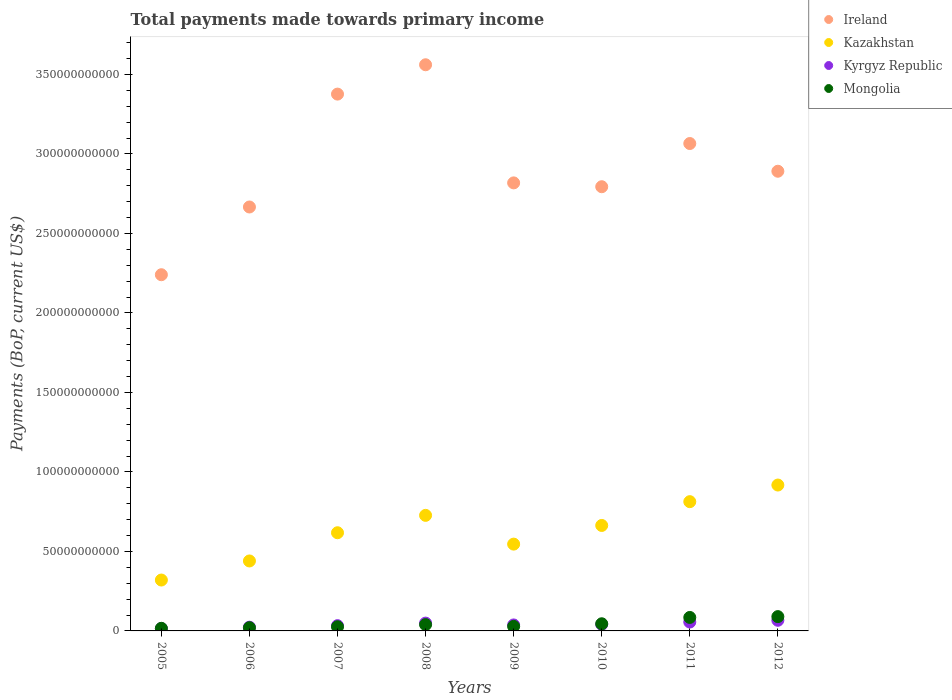How many different coloured dotlines are there?
Offer a very short reply. 4. What is the total payments made towards primary income in Ireland in 2007?
Your answer should be very brief. 3.38e+11. Across all years, what is the maximum total payments made towards primary income in Kyrgyz Republic?
Give a very brief answer. 6.69e+09. Across all years, what is the minimum total payments made towards primary income in Kyrgyz Republic?
Your answer should be very brief. 1.50e+09. In which year was the total payments made towards primary income in Mongolia maximum?
Your response must be concise. 2012. In which year was the total payments made towards primary income in Ireland minimum?
Keep it short and to the point. 2005. What is the total total payments made towards primary income in Mongolia in the graph?
Keep it short and to the point. 3.51e+1. What is the difference between the total payments made towards primary income in Ireland in 2007 and that in 2009?
Make the answer very short. 5.58e+1. What is the difference between the total payments made towards primary income in Kyrgyz Republic in 2005 and the total payments made towards primary income in Mongolia in 2007?
Provide a succinct answer. -1.13e+09. What is the average total payments made towards primary income in Kazakhstan per year?
Keep it short and to the point. 6.31e+1. In the year 2008, what is the difference between the total payments made towards primary income in Kyrgyz Republic and total payments made towards primary income in Ireland?
Your answer should be very brief. -3.51e+11. What is the ratio of the total payments made towards primary income in Ireland in 2010 to that in 2012?
Provide a succinct answer. 0.97. Is the total payments made towards primary income in Kazakhstan in 2008 less than that in 2009?
Provide a succinct answer. No. Is the difference between the total payments made towards primary income in Kyrgyz Republic in 2007 and 2011 greater than the difference between the total payments made towards primary income in Ireland in 2007 and 2011?
Your answer should be compact. No. What is the difference between the highest and the second highest total payments made towards primary income in Mongolia?
Make the answer very short. 5.24e+08. What is the difference between the highest and the lowest total payments made towards primary income in Kyrgyz Republic?
Your answer should be very brief. 5.19e+09. Is the sum of the total payments made towards primary income in Kazakhstan in 2009 and 2010 greater than the maximum total payments made towards primary income in Kyrgyz Republic across all years?
Your answer should be very brief. Yes. Is it the case that in every year, the sum of the total payments made towards primary income in Kazakhstan and total payments made towards primary income in Ireland  is greater than the total payments made towards primary income in Mongolia?
Your answer should be very brief. Yes. How many years are there in the graph?
Keep it short and to the point. 8. What is the difference between two consecutive major ticks on the Y-axis?
Offer a very short reply. 5.00e+1. Where does the legend appear in the graph?
Your answer should be compact. Top right. How are the legend labels stacked?
Make the answer very short. Vertical. What is the title of the graph?
Provide a succinct answer. Total payments made towards primary income. What is the label or title of the X-axis?
Provide a short and direct response. Years. What is the label or title of the Y-axis?
Offer a terse response. Payments (BoP, current US$). What is the Payments (BoP, current US$) in Ireland in 2005?
Make the answer very short. 2.24e+11. What is the Payments (BoP, current US$) in Kazakhstan in 2005?
Give a very brief answer. 3.20e+1. What is the Payments (BoP, current US$) in Kyrgyz Republic in 2005?
Provide a short and direct response. 1.50e+09. What is the Payments (BoP, current US$) in Mongolia in 2005?
Give a very brief answer. 1.63e+09. What is the Payments (BoP, current US$) of Ireland in 2006?
Offer a very short reply. 2.67e+11. What is the Payments (BoP, current US$) in Kazakhstan in 2006?
Make the answer very short. 4.40e+1. What is the Payments (BoP, current US$) in Kyrgyz Republic in 2006?
Offer a terse response. 2.34e+09. What is the Payments (BoP, current US$) in Mongolia in 2006?
Offer a very short reply. 2.04e+09. What is the Payments (BoP, current US$) in Ireland in 2007?
Give a very brief answer. 3.38e+11. What is the Payments (BoP, current US$) of Kazakhstan in 2007?
Ensure brevity in your answer.  6.18e+1. What is the Payments (BoP, current US$) of Kyrgyz Republic in 2007?
Make the answer very short. 3.31e+09. What is the Payments (BoP, current US$) of Mongolia in 2007?
Your response must be concise. 2.63e+09. What is the Payments (BoP, current US$) of Ireland in 2008?
Offer a very short reply. 3.56e+11. What is the Payments (BoP, current US$) in Kazakhstan in 2008?
Make the answer very short. 7.27e+1. What is the Payments (BoP, current US$) of Kyrgyz Republic in 2008?
Ensure brevity in your answer.  4.91e+09. What is the Payments (BoP, current US$) in Mongolia in 2008?
Make the answer very short. 3.96e+09. What is the Payments (BoP, current US$) of Ireland in 2009?
Offer a very short reply. 2.82e+11. What is the Payments (BoP, current US$) in Kazakhstan in 2009?
Give a very brief answer. 5.46e+1. What is the Payments (BoP, current US$) in Kyrgyz Republic in 2009?
Give a very brief answer. 3.76e+09. What is the Payments (BoP, current US$) of Mongolia in 2009?
Ensure brevity in your answer.  2.85e+09. What is the Payments (BoP, current US$) in Ireland in 2010?
Ensure brevity in your answer.  2.79e+11. What is the Payments (BoP, current US$) of Kazakhstan in 2010?
Offer a very short reply. 6.63e+1. What is the Payments (BoP, current US$) of Kyrgyz Republic in 2010?
Your answer should be very brief. 4.12e+09. What is the Payments (BoP, current US$) in Mongolia in 2010?
Keep it short and to the point. 4.50e+09. What is the Payments (BoP, current US$) in Ireland in 2011?
Keep it short and to the point. 3.07e+11. What is the Payments (BoP, current US$) of Kazakhstan in 2011?
Make the answer very short. 8.13e+1. What is the Payments (BoP, current US$) in Kyrgyz Republic in 2011?
Your answer should be compact. 5.59e+09. What is the Payments (BoP, current US$) in Mongolia in 2011?
Give a very brief answer. 8.48e+09. What is the Payments (BoP, current US$) of Ireland in 2012?
Offer a terse response. 2.89e+11. What is the Payments (BoP, current US$) of Kazakhstan in 2012?
Your answer should be very brief. 9.18e+1. What is the Payments (BoP, current US$) in Kyrgyz Republic in 2012?
Offer a very short reply. 6.69e+09. What is the Payments (BoP, current US$) of Mongolia in 2012?
Offer a terse response. 9.00e+09. Across all years, what is the maximum Payments (BoP, current US$) of Ireland?
Provide a short and direct response. 3.56e+11. Across all years, what is the maximum Payments (BoP, current US$) in Kazakhstan?
Ensure brevity in your answer.  9.18e+1. Across all years, what is the maximum Payments (BoP, current US$) of Kyrgyz Republic?
Keep it short and to the point. 6.69e+09. Across all years, what is the maximum Payments (BoP, current US$) of Mongolia?
Provide a succinct answer. 9.00e+09. Across all years, what is the minimum Payments (BoP, current US$) of Ireland?
Make the answer very short. 2.24e+11. Across all years, what is the minimum Payments (BoP, current US$) of Kazakhstan?
Offer a very short reply. 3.20e+1. Across all years, what is the minimum Payments (BoP, current US$) of Kyrgyz Republic?
Keep it short and to the point. 1.50e+09. Across all years, what is the minimum Payments (BoP, current US$) of Mongolia?
Your response must be concise. 1.63e+09. What is the total Payments (BoP, current US$) of Ireland in the graph?
Provide a succinct answer. 2.34e+12. What is the total Payments (BoP, current US$) in Kazakhstan in the graph?
Your answer should be very brief. 5.04e+11. What is the total Payments (BoP, current US$) of Kyrgyz Republic in the graph?
Offer a very short reply. 3.22e+1. What is the total Payments (BoP, current US$) of Mongolia in the graph?
Keep it short and to the point. 3.51e+1. What is the difference between the Payments (BoP, current US$) in Ireland in 2005 and that in 2006?
Make the answer very short. -4.26e+1. What is the difference between the Payments (BoP, current US$) in Kazakhstan in 2005 and that in 2006?
Offer a very short reply. -1.20e+1. What is the difference between the Payments (BoP, current US$) in Kyrgyz Republic in 2005 and that in 2006?
Give a very brief answer. -8.41e+08. What is the difference between the Payments (BoP, current US$) in Mongolia in 2005 and that in 2006?
Your answer should be compact. -4.07e+08. What is the difference between the Payments (BoP, current US$) of Ireland in 2005 and that in 2007?
Provide a succinct answer. -1.14e+11. What is the difference between the Payments (BoP, current US$) in Kazakhstan in 2005 and that in 2007?
Your answer should be compact. -2.97e+1. What is the difference between the Payments (BoP, current US$) of Kyrgyz Republic in 2005 and that in 2007?
Ensure brevity in your answer.  -1.81e+09. What is the difference between the Payments (BoP, current US$) in Mongolia in 2005 and that in 2007?
Your answer should be compact. -9.92e+08. What is the difference between the Payments (BoP, current US$) in Ireland in 2005 and that in 2008?
Ensure brevity in your answer.  -1.32e+11. What is the difference between the Payments (BoP, current US$) in Kazakhstan in 2005 and that in 2008?
Provide a succinct answer. -4.07e+1. What is the difference between the Payments (BoP, current US$) in Kyrgyz Republic in 2005 and that in 2008?
Ensure brevity in your answer.  -3.41e+09. What is the difference between the Payments (BoP, current US$) in Mongolia in 2005 and that in 2008?
Your response must be concise. -2.32e+09. What is the difference between the Payments (BoP, current US$) in Ireland in 2005 and that in 2009?
Ensure brevity in your answer.  -5.78e+1. What is the difference between the Payments (BoP, current US$) of Kazakhstan in 2005 and that in 2009?
Provide a short and direct response. -2.26e+1. What is the difference between the Payments (BoP, current US$) of Kyrgyz Republic in 2005 and that in 2009?
Provide a short and direct response. -2.26e+09. What is the difference between the Payments (BoP, current US$) of Mongolia in 2005 and that in 2009?
Offer a very short reply. -1.22e+09. What is the difference between the Payments (BoP, current US$) in Ireland in 2005 and that in 2010?
Provide a short and direct response. -5.54e+1. What is the difference between the Payments (BoP, current US$) of Kazakhstan in 2005 and that in 2010?
Ensure brevity in your answer.  -3.43e+1. What is the difference between the Payments (BoP, current US$) of Kyrgyz Republic in 2005 and that in 2010?
Offer a very short reply. -2.62e+09. What is the difference between the Payments (BoP, current US$) of Mongolia in 2005 and that in 2010?
Ensure brevity in your answer.  -2.86e+09. What is the difference between the Payments (BoP, current US$) in Ireland in 2005 and that in 2011?
Make the answer very short. -8.25e+1. What is the difference between the Payments (BoP, current US$) in Kazakhstan in 2005 and that in 2011?
Your answer should be compact. -4.93e+1. What is the difference between the Payments (BoP, current US$) in Kyrgyz Republic in 2005 and that in 2011?
Offer a very short reply. -4.09e+09. What is the difference between the Payments (BoP, current US$) of Mongolia in 2005 and that in 2011?
Ensure brevity in your answer.  -6.85e+09. What is the difference between the Payments (BoP, current US$) of Ireland in 2005 and that in 2012?
Provide a succinct answer. -6.51e+1. What is the difference between the Payments (BoP, current US$) in Kazakhstan in 2005 and that in 2012?
Offer a terse response. -5.97e+1. What is the difference between the Payments (BoP, current US$) of Kyrgyz Republic in 2005 and that in 2012?
Offer a terse response. -5.19e+09. What is the difference between the Payments (BoP, current US$) in Mongolia in 2005 and that in 2012?
Your answer should be very brief. -7.37e+09. What is the difference between the Payments (BoP, current US$) of Ireland in 2006 and that in 2007?
Provide a succinct answer. -7.10e+1. What is the difference between the Payments (BoP, current US$) of Kazakhstan in 2006 and that in 2007?
Offer a very short reply. -1.77e+1. What is the difference between the Payments (BoP, current US$) of Kyrgyz Republic in 2006 and that in 2007?
Give a very brief answer. -9.69e+08. What is the difference between the Payments (BoP, current US$) in Mongolia in 2006 and that in 2007?
Your answer should be very brief. -5.85e+08. What is the difference between the Payments (BoP, current US$) of Ireland in 2006 and that in 2008?
Keep it short and to the point. -8.95e+1. What is the difference between the Payments (BoP, current US$) in Kazakhstan in 2006 and that in 2008?
Ensure brevity in your answer.  -2.87e+1. What is the difference between the Payments (BoP, current US$) of Kyrgyz Republic in 2006 and that in 2008?
Give a very brief answer. -2.57e+09. What is the difference between the Payments (BoP, current US$) of Mongolia in 2006 and that in 2008?
Keep it short and to the point. -1.91e+09. What is the difference between the Payments (BoP, current US$) of Ireland in 2006 and that in 2009?
Give a very brief answer. -1.52e+1. What is the difference between the Payments (BoP, current US$) in Kazakhstan in 2006 and that in 2009?
Offer a terse response. -1.06e+1. What is the difference between the Payments (BoP, current US$) of Kyrgyz Republic in 2006 and that in 2009?
Make the answer very short. -1.42e+09. What is the difference between the Payments (BoP, current US$) of Mongolia in 2006 and that in 2009?
Ensure brevity in your answer.  -8.08e+08. What is the difference between the Payments (BoP, current US$) in Ireland in 2006 and that in 2010?
Ensure brevity in your answer.  -1.28e+1. What is the difference between the Payments (BoP, current US$) of Kazakhstan in 2006 and that in 2010?
Give a very brief answer. -2.23e+1. What is the difference between the Payments (BoP, current US$) in Kyrgyz Republic in 2006 and that in 2010?
Give a very brief answer. -1.77e+09. What is the difference between the Payments (BoP, current US$) of Mongolia in 2006 and that in 2010?
Your answer should be very brief. -2.45e+09. What is the difference between the Payments (BoP, current US$) in Ireland in 2006 and that in 2011?
Your answer should be compact. -3.99e+1. What is the difference between the Payments (BoP, current US$) in Kazakhstan in 2006 and that in 2011?
Ensure brevity in your answer.  -3.73e+1. What is the difference between the Payments (BoP, current US$) of Kyrgyz Republic in 2006 and that in 2011?
Offer a very short reply. -3.25e+09. What is the difference between the Payments (BoP, current US$) of Mongolia in 2006 and that in 2011?
Ensure brevity in your answer.  -6.44e+09. What is the difference between the Payments (BoP, current US$) of Ireland in 2006 and that in 2012?
Provide a short and direct response. -2.25e+1. What is the difference between the Payments (BoP, current US$) of Kazakhstan in 2006 and that in 2012?
Ensure brevity in your answer.  -4.77e+1. What is the difference between the Payments (BoP, current US$) in Kyrgyz Republic in 2006 and that in 2012?
Keep it short and to the point. -4.35e+09. What is the difference between the Payments (BoP, current US$) in Mongolia in 2006 and that in 2012?
Provide a short and direct response. -6.96e+09. What is the difference between the Payments (BoP, current US$) in Ireland in 2007 and that in 2008?
Offer a very short reply. -1.85e+1. What is the difference between the Payments (BoP, current US$) of Kazakhstan in 2007 and that in 2008?
Offer a very short reply. -1.09e+1. What is the difference between the Payments (BoP, current US$) in Kyrgyz Republic in 2007 and that in 2008?
Your answer should be very brief. -1.60e+09. What is the difference between the Payments (BoP, current US$) of Mongolia in 2007 and that in 2008?
Provide a short and direct response. -1.33e+09. What is the difference between the Payments (BoP, current US$) of Ireland in 2007 and that in 2009?
Keep it short and to the point. 5.58e+1. What is the difference between the Payments (BoP, current US$) in Kazakhstan in 2007 and that in 2009?
Provide a succinct answer. 7.15e+09. What is the difference between the Payments (BoP, current US$) in Kyrgyz Republic in 2007 and that in 2009?
Provide a short and direct response. -4.52e+08. What is the difference between the Payments (BoP, current US$) in Mongolia in 2007 and that in 2009?
Your answer should be very brief. -2.23e+08. What is the difference between the Payments (BoP, current US$) of Ireland in 2007 and that in 2010?
Offer a terse response. 5.83e+1. What is the difference between the Payments (BoP, current US$) in Kazakhstan in 2007 and that in 2010?
Ensure brevity in your answer.  -4.59e+09. What is the difference between the Payments (BoP, current US$) in Kyrgyz Republic in 2007 and that in 2010?
Make the answer very short. -8.06e+08. What is the difference between the Payments (BoP, current US$) of Mongolia in 2007 and that in 2010?
Give a very brief answer. -1.87e+09. What is the difference between the Payments (BoP, current US$) in Ireland in 2007 and that in 2011?
Ensure brevity in your answer.  3.11e+1. What is the difference between the Payments (BoP, current US$) in Kazakhstan in 2007 and that in 2011?
Your response must be concise. -1.96e+1. What is the difference between the Payments (BoP, current US$) of Kyrgyz Republic in 2007 and that in 2011?
Your answer should be compact. -2.28e+09. What is the difference between the Payments (BoP, current US$) of Mongolia in 2007 and that in 2011?
Offer a very short reply. -5.85e+09. What is the difference between the Payments (BoP, current US$) of Ireland in 2007 and that in 2012?
Offer a terse response. 4.85e+1. What is the difference between the Payments (BoP, current US$) in Kazakhstan in 2007 and that in 2012?
Ensure brevity in your answer.  -3.00e+1. What is the difference between the Payments (BoP, current US$) in Kyrgyz Republic in 2007 and that in 2012?
Offer a very short reply. -3.38e+09. What is the difference between the Payments (BoP, current US$) in Mongolia in 2007 and that in 2012?
Ensure brevity in your answer.  -6.38e+09. What is the difference between the Payments (BoP, current US$) in Ireland in 2008 and that in 2009?
Your answer should be compact. 7.43e+1. What is the difference between the Payments (BoP, current US$) of Kazakhstan in 2008 and that in 2009?
Your answer should be very brief. 1.81e+1. What is the difference between the Payments (BoP, current US$) of Kyrgyz Republic in 2008 and that in 2009?
Make the answer very short. 1.15e+09. What is the difference between the Payments (BoP, current US$) of Mongolia in 2008 and that in 2009?
Provide a succinct answer. 1.11e+09. What is the difference between the Payments (BoP, current US$) of Ireland in 2008 and that in 2010?
Give a very brief answer. 7.67e+1. What is the difference between the Payments (BoP, current US$) of Kazakhstan in 2008 and that in 2010?
Offer a very short reply. 6.35e+09. What is the difference between the Payments (BoP, current US$) of Kyrgyz Republic in 2008 and that in 2010?
Provide a succinct answer. 7.95e+08. What is the difference between the Payments (BoP, current US$) of Mongolia in 2008 and that in 2010?
Provide a succinct answer. -5.40e+08. What is the difference between the Payments (BoP, current US$) in Ireland in 2008 and that in 2011?
Keep it short and to the point. 4.95e+1. What is the difference between the Payments (BoP, current US$) in Kazakhstan in 2008 and that in 2011?
Ensure brevity in your answer.  -8.61e+09. What is the difference between the Payments (BoP, current US$) in Kyrgyz Republic in 2008 and that in 2011?
Your answer should be very brief. -6.79e+08. What is the difference between the Payments (BoP, current US$) in Mongolia in 2008 and that in 2011?
Your response must be concise. -4.52e+09. What is the difference between the Payments (BoP, current US$) in Ireland in 2008 and that in 2012?
Give a very brief answer. 6.70e+1. What is the difference between the Payments (BoP, current US$) of Kazakhstan in 2008 and that in 2012?
Offer a very short reply. -1.91e+1. What is the difference between the Payments (BoP, current US$) of Kyrgyz Republic in 2008 and that in 2012?
Your answer should be compact. -1.78e+09. What is the difference between the Payments (BoP, current US$) of Mongolia in 2008 and that in 2012?
Your answer should be very brief. -5.05e+09. What is the difference between the Payments (BoP, current US$) in Ireland in 2009 and that in 2010?
Offer a terse response. 2.41e+09. What is the difference between the Payments (BoP, current US$) of Kazakhstan in 2009 and that in 2010?
Your response must be concise. -1.17e+1. What is the difference between the Payments (BoP, current US$) of Kyrgyz Republic in 2009 and that in 2010?
Offer a terse response. -3.54e+08. What is the difference between the Payments (BoP, current US$) of Mongolia in 2009 and that in 2010?
Your response must be concise. -1.65e+09. What is the difference between the Payments (BoP, current US$) of Ireland in 2009 and that in 2011?
Provide a short and direct response. -2.48e+1. What is the difference between the Payments (BoP, current US$) in Kazakhstan in 2009 and that in 2011?
Your answer should be very brief. -2.67e+1. What is the difference between the Payments (BoP, current US$) in Kyrgyz Republic in 2009 and that in 2011?
Offer a very short reply. -1.83e+09. What is the difference between the Payments (BoP, current US$) in Mongolia in 2009 and that in 2011?
Give a very brief answer. -5.63e+09. What is the difference between the Payments (BoP, current US$) in Ireland in 2009 and that in 2012?
Your response must be concise. -7.33e+09. What is the difference between the Payments (BoP, current US$) of Kazakhstan in 2009 and that in 2012?
Offer a terse response. -3.72e+1. What is the difference between the Payments (BoP, current US$) in Kyrgyz Republic in 2009 and that in 2012?
Provide a short and direct response. -2.92e+09. What is the difference between the Payments (BoP, current US$) of Mongolia in 2009 and that in 2012?
Give a very brief answer. -6.15e+09. What is the difference between the Payments (BoP, current US$) of Ireland in 2010 and that in 2011?
Your answer should be very brief. -2.72e+1. What is the difference between the Payments (BoP, current US$) of Kazakhstan in 2010 and that in 2011?
Make the answer very short. -1.50e+1. What is the difference between the Payments (BoP, current US$) in Kyrgyz Republic in 2010 and that in 2011?
Your response must be concise. -1.47e+09. What is the difference between the Payments (BoP, current US$) in Mongolia in 2010 and that in 2011?
Offer a terse response. -3.98e+09. What is the difference between the Payments (BoP, current US$) in Ireland in 2010 and that in 2012?
Provide a succinct answer. -9.74e+09. What is the difference between the Payments (BoP, current US$) in Kazakhstan in 2010 and that in 2012?
Your answer should be very brief. -2.54e+1. What is the difference between the Payments (BoP, current US$) in Kyrgyz Republic in 2010 and that in 2012?
Ensure brevity in your answer.  -2.57e+09. What is the difference between the Payments (BoP, current US$) of Mongolia in 2010 and that in 2012?
Make the answer very short. -4.51e+09. What is the difference between the Payments (BoP, current US$) in Ireland in 2011 and that in 2012?
Offer a terse response. 1.74e+1. What is the difference between the Payments (BoP, current US$) in Kazakhstan in 2011 and that in 2012?
Keep it short and to the point. -1.05e+1. What is the difference between the Payments (BoP, current US$) of Kyrgyz Republic in 2011 and that in 2012?
Your answer should be compact. -1.10e+09. What is the difference between the Payments (BoP, current US$) of Mongolia in 2011 and that in 2012?
Give a very brief answer. -5.24e+08. What is the difference between the Payments (BoP, current US$) of Ireland in 2005 and the Payments (BoP, current US$) of Kazakhstan in 2006?
Your response must be concise. 1.80e+11. What is the difference between the Payments (BoP, current US$) in Ireland in 2005 and the Payments (BoP, current US$) in Kyrgyz Republic in 2006?
Keep it short and to the point. 2.22e+11. What is the difference between the Payments (BoP, current US$) in Ireland in 2005 and the Payments (BoP, current US$) in Mongolia in 2006?
Your answer should be very brief. 2.22e+11. What is the difference between the Payments (BoP, current US$) in Kazakhstan in 2005 and the Payments (BoP, current US$) in Kyrgyz Republic in 2006?
Offer a very short reply. 2.97e+1. What is the difference between the Payments (BoP, current US$) in Kazakhstan in 2005 and the Payments (BoP, current US$) in Mongolia in 2006?
Provide a succinct answer. 3.00e+1. What is the difference between the Payments (BoP, current US$) in Kyrgyz Republic in 2005 and the Payments (BoP, current US$) in Mongolia in 2006?
Provide a succinct answer. -5.41e+08. What is the difference between the Payments (BoP, current US$) in Ireland in 2005 and the Payments (BoP, current US$) in Kazakhstan in 2007?
Offer a terse response. 1.62e+11. What is the difference between the Payments (BoP, current US$) of Ireland in 2005 and the Payments (BoP, current US$) of Kyrgyz Republic in 2007?
Your answer should be compact. 2.21e+11. What is the difference between the Payments (BoP, current US$) of Ireland in 2005 and the Payments (BoP, current US$) of Mongolia in 2007?
Your answer should be compact. 2.21e+11. What is the difference between the Payments (BoP, current US$) of Kazakhstan in 2005 and the Payments (BoP, current US$) of Kyrgyz Republic in 2007?
Give a very brief answer. 2.87e+1. What is the difference between the Payments (BoP, current US$) in Kazakhstan in 2005 and the Payments (BoP, current US$) in Mongolia in 2007?
Your answer should be compact. 2.94e+1. What is the difference between the Payments (BoP, current US$) of Kyrgyz Republic in 2005 and the Payments (BoP, current US$) of Mongolia in 2007?
Your answer should be compact. -1.13e+09. What is the difference between the Payments (BoP, current US$) in Ireland in 2005 and the Payments (BoP, current US$) in Kazakhstan in 2008?
Give a very brief answer. 1.51e+11. What is the difference between the Payments (BoP, current US$) in Ireland in 2005 and the Payments (BoP, current US$) in Kyrgyz Republic in 2008?
Your answer should be compact. 2.19e+11. What is the difference between the Payments (BoP, current US$) of Ireland in 2005 and the Payments (BoP, current US$) of Mongolia in 2008?
Your answer should be compact. 2.20e+11. What is the difference between the Payments (BoP, current US$) in Kazakhstan in 2005 and the Payments (BoP, current US$) in Kyrgyz Republic in 2008?
Make the answer very short. 2.71e+1. What is the difference between the Payments (BoP, current US$) of Kazakhstan in 2005 and the Payments (BoP, current US$) of Mongolia in 2008?
Provide a short and direct response. 2.81e+1. What is the difference between the Payments (BoP, current US$) of Kyrgyz Republic in 2005 and the Payments (BoP, current US$) of Mongolia in 2008?
Your answer should be very brief. -2.46e+09. What is the difference between the Payments (BoP, current US$) of Ireland in 2005 and the Payments (BoP, current US$) of Kazakhstan in 2009?
Offer a very short reply. 1.69e+11. What is the difference between the Payments (BoP, current US$) in Ireland in 2005 and the Payments (BoP, current US$) in Kyrgyz Republic in 2009?
Ensure brevity in your answer.  2.20e+11. What is the difference between the Payments (BoP, current US$) of Ireland in 2005 and the Payments (BoP, current US$) of Mongolia in 2009?
Your answer should be very brief. 2.21e+11. What is the difference between the Payments (BoP, current US$) of Kazakhstan in 2005 and the Payments (BoP, current US$) of Kyrgyz Republic in 2009?
Make the answer very short. 2.82e+1. What is the difference between the Payments (BoP, current US$) of Kazakhstan in 2005 and the Payments (BoP, current US$) of Mongolia in 2009?
Give a very brief answer. 2.92e+1. What is the difference between the Payments (BoP, current US$) of Kyrgyz Republic in 2005 and the Payments (BoP, current US$) of Mongolia in 2009?
Provide a succinct answer. -1.35e+09. What is the difference between the Payments (BoP, current US$) in Ireland in 2005 and the Payments (BoP, current US$) in Kazakhstan in 2010?
Your response must be concise. 1.58e+11. What is the difference between the Payments (BoP, current US$) in Ireland in 2005 and the Payments (BoP, current US$) in Kyrgyz Republic in 2010?
Ensure brevity in your answer.  2.20e+11. What is the difference between the Payments (BoP, current US$) in Ireland in 2005 and the Payments (BoP, current US$) in Mongolia in 2010?
Offer a terse response. 2.20e+11. What is the difference between the Payments (BoP, current US$) of Kazakhstan in 2005 and the Payments (BoP, current US$) of Kyrgyz Republic in 2010?
Ensure brevity in your answer.  2.79e+1. What is the difference between the Payments (BoP, current US$) of Kazakhstan in 2005 and the Payments (BoP, current US$) of Mongolia in 2010?
Make the answer very short. 2.75e+1. What is the difference between the Payments (BoP, current US$) in Kyrgyz Republic in 2005 and the Payments (BoP, current US$) in Mongolia in 2010?
Give a very brief answer. -3.00e+09. What is the difference between the Payments (BoP, current US$) in Ireland in 2005 and the Payments (BoP, current US$) in Kazakhstan in 2011?
Make the answer very short. 1.43e+11. What is the difference between the Payments (BoP, current US$) in Ireland in 2005 and the Payments (BoP, current US$) in Kyrgyz Republic in 2011?
Provide a succinct answer. 2.18e+11. What is the difference between the Payments (BoP, current US$) in Ireland in 2005 and the Payments (BoP, current US$) in Mongolia in 2011?
Offer a terse response. 2.16e+11. What is the difference between the Payments (BoP, current US$) of Kazakhstan in 2005 and the Payments (BoP, current US$) of Kyrgyz Republic in 2011?
Provide a succinct answer. 2.64e+1. What is the difference between the Payments (BoP, current US$) in Kazakhstan in 2005 and the Payments (BoP, current US$) in Mongolia in 2011?
Your response must be concise. 2.35e+1. What is the difference between the Payments (BoP, current US$) of Kyrgyz Republic in 2005 and the Payments (BoP, current US$) of Mongolia in 2011?
Offer a terse response. -6.98e+09. What is the difference between the Payments (BoP, current US$) of Ireland in 2005 and the Payments (BoP, current US$) of Kazakhstan in 2012?
Your answer should be very brief. 1.32e+11. What is the difference between the Payments (BoP, current US$) in Ireland in 2005 and the Payments (BoP, current US$) in Kyrgyz Republic in 2012?
Your response must be concise. 2.17e+11. What is the difference between the Payments (BoP, current US$) in Ireland in 2005 and the Payments (BoP, current US$) in Mongolia in 2012?
Provide a succinct answer. 2.15e+11. What is the difference between the Payments (BoP, current US$) in Kazakhstan in 2005 and the Payments (BoP, current US$) in Kyrgyz Republic in 2012?
Ensure brevity in your answer.  2.53e+1. What is the difference between the Payments (BoP, current US$) in Kazakhstan in 2005 and the Payments (BoP, current US$) in Mongolia in 2012?
Provide a succinct answer. 2.30e+1. What is the difference between the Payments (BoP, current US$) of Kyrgyz Republic in 2005 and the Payments (BoP, current US$) of Mongolia in 2012?
Make the answer very short. -7.50e+09. What is the difference between the Payments (BoP, current US$) in Ireland in 2006 and the Payments (BoP, current US$) in Kazakhstan in 2007?
Your answer should be compact. 2.05e+11. What is the difference between the Payments (BoP, current US$) in Ireland in 2006 and the Payments (BoP, current US$) in Kyrgyz Republic in 2007?
Provide a short and direct response. 2.63e+11. What is the difference between the Payments (BoP, current US$) in Ireland in 2006 and the Payments (BoP, current US$) in Mongolia in 2007?
Provide a short and direct response. 2.64e+11. What is the difference between the Payments (BoP, current US$) of Kazakhstan in 2006 and the Payments (BoP, current US$) of Kyrgyz Republic in 2007?
Keep it short and to the point. 4.07e+1. What is the difference between the Payments (BoP, current US$) in Kazakhstan in 2006 and the Payments (BoP, current US$) in Mongolia in 2007?
Make the answer very short. 4.14e+1. What is the difference between the Payments (BoP, current US$) in Kyrgyz Republic in 2006 and the Payments (BoP, current US$) in Mongolia in 2007?
Give a very brief answer. -2.85e+08. What is the difference between the Payments (BoP, current US$) in Ireland in 2006 and the Payments (BoP, current US$) in Kazakhstan in 2008?
Your response must be concise. 1.94e+11. What is the difference between the Payments (BoP, current US$) in Ireland in 2006 and the Payments (BoP, current US$) in Kyrgyz Republic in 2008?
Keep it short and to the point. 2.62e+11. What is the difference between the Payments (BoP, current US$) of Ireland in 2006 and the Payments (BoP, current US$) of Mongolia in 2008?
Offer a very short reply. 2.63e+11. What is the difference between the Payments (BoP, current US$) of Kazakhstan in 2006 and the Payments (BoP, current US$) of Kyrgyz Republic in 2008?
Give a very brief answer. 3.91e+1. What is the difference between the Payments (BoP, current US$) in Kazakhstan in 2006 and the Payments (BoP, current US$) in Mongolia in 2008?
Offer a very short reply. 4.01e+1. What is the difference between the Payments (BoP, current US$) in Kyrgyz Republic in 2006 and the Payments (BoP, current US$) in Mongolia in 2008?
Your answer should be compact. -1.61e+09. What is the difference between the Payments (BoP, current US$) of Ireland in 2006 and the Payments (BoP, current US$) of Kazakhstan in 2009?
Offer a very short reply. 2.12e+11. What is the difference between the Payments (BoP, current US$) in Ireland in 2006 and the Payments (BoP, current US$) in Kyrgyz Republic in 2009?
Make the answer very short. 2.63e+11. What is the difference between the Payments (BoP, current US$) of Ireland in 2006 and the Payments (BoP, current US$) of Mongolia in 2009?
Offer a very short reply. 2.64e+11. What is the difference between the Payments (BoP, current US$) of Kazakhstan in 2006 and the Payments (BoP, current US$) of Kyrgyz Republic in 2009?
Provide a short and direct response. 4.02e+1. What is the difference between the Payments (BoP, current US$) of Kazakhstan in 2006 and the Payments (BoP, current US$) of Mongolia in 2009?
Offer a terse response. 4.12e+1. What is the difference between the Payments (BoP, current US$) in Kyrgyz Republic in 2006 and the Payments (BoP, current US$) in Mongolia in 2009?
Offer a very short reply. -5.08e+08. What is the difference between the Payments (BoP, current US$) of Ireland in 2006 and the Payments (BoP, current US$) of Kazakhstan in 2010?
Provide a succinct answer. 2.00e+11. What is the difference between the Payments (BoP, current US$) of Ireland in 2006 and the Payments (BoP, current US$) of Kyrgyz Republic in 2010?
Offer a terse response. 2.63e+11. What is the difference between the Payments (BoP, current US$) of Ireland in 2006 and the Payments (BoP, current US$) of Mongolia in 2010?
Your answer should be very brief. 2.62e+11. What is the difference between the Payments (BoP, current US$) of Kazakhstan in 2006 and the Payments (BoP, current US$) of Kyrgyz Republic in 2010?
Keep it short and to the point. 3.99e+1. What is the difference between the Payments (BoP, current US$) in Kazakhstan in 2006 and the Payments (BoP, current US$) in Mongolia in 2010?
Your answer should be very brief. 3.95e+1. What is the difference between the Payments (BoP, current US$) in Kyrgyz Republic in 2006 and the Payments (BoP, current US$) in Mongolia in 2010?
Make the answer very short. -2.15e+09. What is the difference between the Payments (BoP, current US$) in Ireland in 2006 and the Payments (BoP, current US$) in Kazakhstan in 2011?
Your answer should be compact. 1.85e+11. What is the difference between the Payments (BoP, current US$) of Ireland in 2006 and the Payments (BoP, current US$) of Kyrgyz Republic in 2011?
Provide a short and direct response. 2.61e+11. What is the difference between the Payments (BoP, current US$) of Ireland in 2006 and the Payments (BoP, current US$) of Mongolia in 2011?
Your answer should be very brief. 2.58e+11. What is the difference between the Payments (BoP, current US$) of Kazakhstan in 2006 and the Payments (BoP, current US$) of Kyrgyz Republic in 2011?
Provide a succinct answer. 3.84e+1. What is the difference between the Payments (BoP, current US$) in Kazakhstan in 2006 and the Payments (BoP, current US$) in Mongolia in 2011?
Offer a terse response. 3.55e+1. What is the difference between the Payments (BoP, current US$) in Kyrgyz Republic in 2006 and the Payments (BoP, current US$) in Mongolia in 2011?
Offer a terse response. -6.14e+09. What is the difference between the Payments (BoP, current US$) in Ireland in 2006 and the Payments (BoP, current US$) in Kazakhstan in 2012?
Provide a short and direct response. 1.75e+11. What is the difference between the Payments (BoP, current US$) in Ireland in 2006 and the Payments (BoP, current US$) in Kyrgyz Republic in 2012?
Ensure brevity in your answer.  2.60e+11. What is the difference between the Payments (BoP, current US$) of Ireland in 2006 and the Payments (BoP, current US$) of Mongolia in 2012?
Keep it short and to the point. 2.58e+11. What is the difference between the Payments (BoP, current US$) of Kazakhstan in 2006 and the Payments (BoP, current US$) of Kyrgyz Republic in 2012?
Keep it short and to the point. 3.73e+1. What is the difference between the Payments (BoP, current US$) in Kazakhstan in 2006 and the Payments (BoP, current US$) in Mongolia in 2012?
Your answer should be very brief. 3.50e+1. What is the difference between the Payments (BoP, current US$) in Kyrgyz Republic in 2006 and the Payments (BoP, current US$) in Mongolia in 2012?
Your response must be concise. -6.66e+09. What is the difference between the Payments (BoP, current US$) of Ireland in 2007 and the Payments (BoP, current US$) of Kazakhstan in 2008?
Your answer should be very brief. 2.65e+11. What is the difference between the Payments (BoP, current US$) in Ireland in 2007 and the Payments (BoP, current US$) in Kyrgyz Republic in 2008?
Your answer should be compact. 3.33e+11. What is the difference between the Payments (BoP, current US$) of Ireland in 2007 and the Payments (BoP, current US$) of Mongolia in 2008?
Offer a terse response. 3.34e+11. What is the difference between the Payments (BoP, current US$) in Kazakhstan in 2007 and the Payments (BoP, current US$) in Kyrgyz Republic in 2008?
Give a very brief answer. 5.68e+1. What is the difference between the Payments (BoP, current US$) of Kazakhstan in 2007 and the Payments (BoP, current US$) of Mongolia in 2008?
Offer a terse response. 5.78e+1. What is the difference between the Payments (BoP, current US$) of Kyrgyz Republic in 2007 and the Payments (BoP, current US$) of Mongolia in 2008?
Offer a terse response. -6.44e+08. What is the difference between the Payments (BoP, current US$) of Ireland in 2007 and the Payments (BoP, current US$) of Kazakhstan in 2009?
Provide a short and direct response. 2.83e+11. What is the difference between the Payments (BoP, current US$) of Ireland in 2007 and the Payments (BoP, current US$) of Kyrgyz Republic in 2009?
Provide a short and direct response. 3.34e+11. What is the difference between the Payments (BoP, current US$) in Ireland in 2007 and the Payments (BoP, current US$) in Mongolia in 2009?
Offer a very short reply. 3.35e+11. What is the difference between the Payments (BoP, current US$) of Kazakhstan in 2007 and the Payments (BoP, current US$) of Kyrgyz Republic in 2009?
Give a very brief answer. 5.80e+1. What is the difference between the Payments (BoP, current US$) of Kazakhstan in 2007 and the Payments (BoP, current US$) of Mongolia in 2009?
Make the answer very short. 5.89e+1. What is the difference between the Payments (BoP, current US$) in Kyrgyz Republic in 2007 and the Payments (BoP, current US$) in Mongolia in 2009?
Ensure brevity in your answer.  4.62e+08. What is the difference between the Payments (BoP, current US$) of Ireland in 2007 and the Payments (BoP, current US$) of Kazakhstan in 2010?
Your answer should be very brief. 2.71e+11. What is the difference between the Payments (BoP, current US$) of Ireland in 2007 and the Payments (BoP, current US$) of Kyrgyz Republic in 2010?
Give a very brief answer. 3.34e+11. What is the difference between the Payments (BoP, current US$) in Ireland in 2007 and the Payments (BoP, current US$) in Mongolia in 2010?
Ensure brevity in your answer.  3.33e+11. What is the difference between the Payments (BoP, current US$) of Kazakhstan in 2007 and the Payments (BoP, current US$) of Kyrgyz Republic in 2010?
Provide a short and direct response. 5.76e+1. What is the difference between the Payments (BoP, current US$) of Kazakhstan in 2007 and the Payments (BoP, current US$) of Mongolia in 2010?
Give a very brief answer. 5.73e+1. What is the difference between the Payments (BoP, current US$) in Kyrgyz Republic in 2007 and the Payments (BoP, current US$) in Mongolia in 2010?
Provide a short and direct response. -1.18e+09. What is the difference between the Payments (BoP, current US$) in Ireland in 2007 and the Payments (BoP, current US$) in Kazakhstan in 2011?
Your answer should be very brief. 2.56e+11. What is the difference between the Payments (BoP, current US$) in Ireland in 2007 and the Payments (BoP, current US$) in Kyrgyz Republic in 2011?
Offer a terse response. 3.32e+11. What is the difference between the Payments (BoP, current US$) of Ireland in 2007 and the Payments (BoP, current US$) of Mongolia in 2011?
Ensure brevity in your answer.  3.29e+11. What is the difference between the Payments (BoP, current US$) in Kazakhstan in 2007 and the Payments (BoP, current US$) in Kyrgyz Republic in 2011?
Keep it short and to the point. 5.62e+1. What is the difference between the Payments (BoP, current US$) in Kazakhstan in 2007 and the Payments (BoP, current US$) in Mongolia in 2011?
Provide a succinct answer. 5.33e+1. What is the difference between the Payments (BoP, current US$) in Kyrgyz Republic in 2007 and the Payments (BoP, current US$) in Mongolia in 2011?
Your answer should be compact. -5.17e+09. What is the difference between the Payments (BoP, current US$) of Ireland in 2007 and the Payments (BoP, current US$) of Kazakhstan in 2012?
Give a very brief answer. 2.46e+11. What is the difference between the Payments (BoP, current US$) of Ireland in 2007 and the Payments (BoP, current US$) of Kyrgyz Republic in 2012?
Make the answer very short. 3.31e+11. What is the difference between the Payments (BoP, current US$) of Ireland in 2007 and the Payments (BoP, current US$) of Mongolia in 2012?
Give a very brief answer. 3.29e+11. What is the difference between the Payments (BoP, current US$) in Kazakhstan in 2007 and the Payments (BoP, current US$) in Kyrgyz Republic in 2012?
Your response must be concise. 5.51e+1. What is the difference between the Payments (BoP, current US$) of Kazakhstan in 2007 and the Payments (BoP, current US$) of Mongolia in 2012?
Provide a succinct answer. 5.27e+1. What is the difference between the Payments (BoP, current US$) in Kyrgyz Republic in 2007 and the Payments (BoP, current US$) in Mongolia in 2012?
Provide a succinct answer. -5.69e+09. What is the difference between the Payments (BoP, current US$) in Ireland in 2008 and the Payments (BoP, current US$) in Kazakhstan in 2009?
Offer a terse response. 3.02e+11. What is the difference between the Payments (BoP, current US$) in Ireland in 2008 and the Payments (BoP, current US$) in Kyrgyz Republic in 2009?
Your answer should be compact. 3.52e+11. What is the difference between the Payments (BoP, current US$) of Ireland in 2008 and the Payments (BoP, current US$) of Mongolia in 2009?
Give a very brief answer. 3.53e+11. What is the difference between the Payments (BoP, current US$) in Kazakhstan in 2008 and the Payments (BoP, current US$) in Kyrgyz Republic in 2009?
Your response must be concise. 6.89e+1. What is the difference between the Payments (BoP, current US$) in Kazakhstan in 2008 and the Payments (BoP, current US$) in Mongolia in 2009?
Your answer should be compact. 6.98e+1. What is the difference between the Payments (BoP, current US$) of Kyrgyz Republic in 2008 and the Payments (BoP, current US$) of Mongolia in 2009?
Offer a terse response. 2.06e+09. What is the difference between the Payments (BoP, current US$) of Ireland in 2008 and the Payments (BoP, current US$) of Kazakhstan in 2010?
Your answer should be very brief. 2.90e+11. What is the difference between the Payments (BoP, current US$) of Ireland in 2008 and the Payments (BoP, current US$) of Kyrgyz Republic in 2010?
Ensure brevity in your answer.  3.52e+11. What is the difference between the Payments (BoP, current US$) of Ireland in 2008 and the Payments (BoP, current US$) of Mongolia in 2010?
Make the answer very short. 3.52e+11. What is the difference between the Payments (BoP, current US$) in Kazakhstan in 2008 and the Payments (BoP, current US$) in Kyrgyz Republic in 2010?
Make the answer very short. 6.86e+1. What is the difference between the Payments (BoP, current US$) of Kazakhstan in 2008 and the Payments (BoP, current US$) of Mongolia in 2010?
Your answer should be compact. 6.82e+1. What is the difference between the Payments (BoP, current US$) of Kyrgyz Republic in 2008 and the Payments (BoP, current US$) of Mongolia in 2010?
Make the answer very short. 4.16e+08. What is the difference between the Payments (BoP, current US$) in Ireland in 2008 and the Payments (BoP, current US$) in Kazakhstan in 2011?
Provide a succinct answer. 2.75e+11. What is the difference between the Payments (BoP, current US$) in Ireland in 2008 and the Payments (BoP, current US$) in Kyrgyz Republic in 2011?
Provide a succinct answer. 3.51e+11. What is the difference between the Payments (BoP, current US$) of Ireland in 2008 and the Payments (BoP, current US$) of Mongolia in 2011?
Ensure brevity in your answer.  3.48e+11. What is the difference between the Payments (BoP, current US$) of Kazakhstan in 2008 and the Payments (BoP, current US$) of Kyrgyz Republic in 2011?
Offer a terse response. 6.71e+1. What is the difference between the Payments (BoP, current US$) of Kazakhstan in 2008 and the Payments (BoP, current US$) of Mongolia in 2011?
Offer a terse response. 6.42e+1. What is the difference between the Payments (BoP, current US$) of Kyrgyz Republic in 2008 and the Payments (BoP, current US$) of Mongolia in 2011?
Your answer should be compact. -3.57e+09. What is the difference between the Payments (BoP, current US$) of Ireland in 2008 and the Payments (BoP, current US$) of Kazakhstan in 2012?
Keep it short and to the point. 2.64e+11. What is the difference between the Payments (BoP, current US$) of Ireland in 2008 and the Payments (BoP, current US$) of Kyrgyz Republic in 2012?
Make the answer very short. 3.49e+11. What is the difference between the Payments (BoP, current US$) in Ireland in 2008 and the Payments (BoP, current US$) in Mongolia in 2012?
Keep it short and to the point. 3.47e+11. What is the difference between the Payments (BoP, current US$) in Kazakhstan in 2008 and the Payments (BoP, current US$) in Kyrgyz Republic in 2012?
Ensure brevity in your answer.  6.60e+1. What is the difference between the Payments (BoP, current US$) in Kazakhstan in 2008 and the Payments (BoP, current US$) in Mongolia in 2012?
Your response must be concise. 6.37e+1. What is the difference between the Payments (BoP, current US$) of Kyrgyz Republic in 2008 and the Payments (BoP, current US$) of Mongolia in 2012?
Provide a succinct answer. -4.09e+09. What is the difference between the Payments (BoP, current US$) of Ireland in 2009 and the Payments (BoP, current US$) of Kazakhstan in 2010?
Offer a very short reply. 2.15e+11. What is the difference between the Payments (BoP, current US$) in Ireland in 2009 and the Payments (BoP, current US$) in Kyrgyz Republic in 2010?
Your answer should be compact. 2.78e+11. What is the difference between the Payments (BoP, current US$) in Ireland in 2009 and the Payments (BoP, current US$) in Mongolia in 2010?
Offer a terse response. 2.77e+11. What is the difference between the Payments (BoP, current US$) in Kazakhstan in 2009 and the Payments (BoP, current US$) in Kyrgyz Republic in 2010?
Offer a very short reply. 5.05e+1. What is the difference between the Payments (BoP, current US$) in Kazakhstan in 2009 and the Payments (BoP, current US$) in Mongolia in 2010?
Offer a terse response. 5.01e+1. What is the difference between the Payments (BoP, current US$) in Kyrgyz Republic in 2009 and the Payments (BoP, current US$) in Mongolia in 2010?
Your answer should be compact. -7.33e+08. What is the difference between the Payments (BoP, current US$) in Ireland in 2009 and the Payments (BoP, current US$) in Kazakhstan in 2011?
Provide a short and direct response. 2.01e+11. What is the difference between the Payments (BoP, current US$) of Ireland in 2009 and the Payments (BoP, current US$) of Kyrgyz Republic in 2011?
Ensure brevity in your answer.  2.76e+11. What is the difference between the Payments (BoP, current US$) of Ireland in 2009 and the Payments (BoP, current US$) of Mongolia in 2011?
Your answer should be compact. 2.73e+11. What is the difference between the Payments (BoP, current US$) in Kazakhstan in 2009 and the Payments (BoP, current US$) in Kyrgyz Republic in 2011?
Make the answer very short. 4.90e+1. What is the difference between the Payments (BoP, current US$) in Kazakhstan in 2009 and the Payments (BoP, current US$) in Mongolia in 2011?
Offer a very short reply. 4.61e+1. What is the difference between the Payments (BoP, current US$) in Kyrgyz Republic in 2009 and the Payments (BoP, current US$) in Mongolia in 2011?
Provide a short and direct response. -4.72e+09. What is the difference between the Payments (BoP, current US$) of Ireland in 2009 and the Payments (BoP, current US$) of Kazakhstan in 2012?
Offer a very short reply. 1.90e+11. What is the difference between the Payments (BoP, current US$) in Ireland in 2009 and the Payments (BoP, current US$) in Kyrgyz Republic in 2012?
Your response must be concise. 2.75e+11. What is the difference between the Payments (BoP, current US$) in Ireland in 2009 and the Payments (BoP, current US$) in Mongolia in 2012?
Offer a very short reply. 2.73e+11. What is the difference between the Payments (BoP, current US$) of Kazakhstan in 2009 and the Payments (BoP, current US$) of Kyrgyz Republic in 2012?
Make the answer very short. 4.79e+1. What is the difference between the Payments (BoP, current US$) of Kazakhstan in 2009 and the Payments (BoP, current US$) of Mongolia in 2012?
Offer a terse response. 4.56e+1. What is the difference between the Payments (BoP, current US$) in Kyrgyz Republic in 2009 and the Payments (BoP, current US$) in Mongolia in 2012?
Offer a very short reply. -5.24e+09. What is the difference between the Payments (BoP, current US$) in Ireland in 2010 and the Payments (BoP, current US$) in Kazakhstan in 2011?
Give a very brief answer. 1.98e+11. What is the difference between the Payments (BoP, current US$) of Ireland in 2010 and the Payments (BoP, current US$) of Kyrgyz Republic in 2011?
Make the answer very short. 2.74e+11. What is the difference between the Payments (BoP, current US$) in Ireland in 2010 and the Payments (BoP, current US$) in Mongolia in 2011?
Your response must be concise. 2.71e+11. What is the difference between the Payments (BoP, current US$) of Kazakhstan in 2010 and the Payments (BoP, current US$) of Kyrgyz Republic in 2011?
Give a very brief answer. 6.07e+1. What is the difference between the Payments (BoP, current US$) of Kazakhstan in 2010 and the Payments (BoP, current US$) of Mongolia in 2011?
Provide a succinct answer. 5.79e+1. What is the difference between the Payments (BoP, current US$) in Kyrgyz Republic in 2010 and the Payments (BoP, current US$) in Mongolia in 2011?
Keep it short and to the point. -4.36e+09. What is the difference between the Payments (BoP, current US$) in Ireland in 2010 and the Payments (BoP, current US$) in Kazakhstan in 2012?
Keep it short and to the point. 1.88e+11. What is the difference between the Payments (BoP, current US$) in Ireland in 2010 and the Payments (BoP, current US$) in Kyrgyz Republic in 2012?
Offer a terse response. 2.73e+11. What is the difference between the Payments (BoP, current US$) of Ireland in 2010 and the Payments (BoP, current US$) of Mongolia in 2012?
Offer a terse response. 2.70e+11. What is the difference between the Payments (BoP, current US$) of Kazakhstan in 2010 and the Payments (BoP, current US$) of Kyrgyz Republic in 2012?
Your answer should be compact. 5.96e+1. What is the difference between the Payments (BoP, current US$) in Kazakhstan in 2010 and the Payments (BoP, current US$) in Mongolia in 2012?
Ensure brevity in your answer.  5.73e+1. What is the difference between the Payments (BoP, current US$) of Kyrgyz Republic in 2010 and the Payments (BoP, current US$) of Mongolia in 2012?
Your answer should be very brief. -4.89e+09. What is the difference between the Payments (BoP, current US$) of Ireland in 2011 and the Payments (BoP, current US$) of Kazakhstan in 2012?
Provide a short and direct response. 2.15e+11. What is the difference between the Payments (BoP, current US$) in Ireland in 2011 and the Payments (BoP, current US$) in Kyrgyz Republic in 2012?
Provide a succinct answer. 3.00e+11. What is the difference between the Payments (BoP, current US$) of Ireland in 2011 and the Payments (BoP, current US$) of Mongolia in 2012?
Your answer should be very brief. 2.98e+11. What is the difference between the Payments (BoP, current US$) of Kazakhstan in 2011 and the Payments (BoP, current US$) of Kyrgyz Republic in 2012?
Provide a short and direct response. 7.46e+1. What is the difference between the Payments (BoP, current US$) of Kazakhstan in 2011 and the Payments (BoP, current US$) of Mongolia in 2012?
Keep it short and to the point. 7.23e+1. What is the difference between the Payments (BoP, current US$) in Kyrgyz Republic in 2011 and the Payments (BoP, current US$) in Mongolia in 2012?
Keep it short and to the point. -3.41e+09. What is the average Payments (BoP, current US$) in Ireland per year?
Offer a very short reply. 2.93e+11. What is the average Payments (BoP, current US$) of Kazakhstan per year?
Your answer should be very brief. 6.31e+1. What is the average Payments (BoP, current US$) in Kyrgyz Republic per year?
Offer a very short reply. 4.03e+09. What is the average Payments (BoP, current US$) in Mongolia per year?
Make the answer very short. 4.39e+09. In the year 2005, what is the difference between the Payments (BoP, current US$) of Ireland and Payments (BoP, current US$) of Kazakhstan?
Provide a succinct answer. 1.92e+11. In the year 2005, what is the difference between the Payments (BoP, current US$) of Ireland and Payments (BoP, current US$) of Kyrgyz Republic?
Your answer should be compact. 2.23e+11. In the year 2005, what is the difference between the Payments (BoP, current US$) of Ireland and Payments (BoP, current US$) of Mongolia?
Your response must be concise. 2.22e+11. In the year 2005, what is the difference between the Payments (BoP, current US$) of Kazakhstan and Payments (BoP, current US$) of Kyrgyz Republic?
Offer a terse response. 3.05e+1. In the year 2005, what is the difference between the Payments (BoP, current US$) of Kazakhstan and Payments (BoP, current US$) of Mongolia?
Offer a very short reply. 3.04e+1. In the year 2005, what is the difference between the Payments (BoP, current US$) in Kyrgyz Republic and Payments (BoP, current US$) in Mongolia?
Give a very brief answer. -1.34e+08. In the year 2006, what is the difference between the Payments (BoP, current US$) in Ireland and Payments (BoP, current US$) in Kazakhstan?
Provide a succinct answer. 2.23e+11. In the year 2006, what is the difference between the Payments (BoP, current US$) of Ireland and Payments (BoP, current US$) of Kyrgyz Republic?
Give a very brief answer. 2.64e+11. In the year 2006, what is the difference between the Payments (BoP, current US$) in Ireland and Payments (BoP, current US$) in Mongolia?
Offer a terse response. 2.65e+11. In the year 2006, what is the difference between the Payments (BoP, current US$) in Kazakhstan and Payments (BoP, current US$) in Kyrgyz Republic?
Offer a terse response. 4.17e+1. In the year 2006, what is the difference between the Payments (BoP, current US$) of Kazakhstan and Payments (BoP, current US$) of Mongolia?
Offer a very short reply. 4.20e+1. In the year 2006, what is the difference between the Payments (BoP, current US$) of Kyrgyz Republic and Payments (BoP, current US$) of Mongolia?
Provide a short and direct response. 3.00e+08. In the year 2007, what is the difference between the Payments (BoP, current US$) of Ireland and Payments (BoP, current US$) of Kazakhstan?
Keep it short and to the point. 2.76e+11. In the year 2007, what is the difference between the Payments (BoP, current US$) of Ireland and Payments (BoP, current US$) of Kyrgyz Republic?
Ensure brevity in your answer.  3.34e+11. In the year 2007, what is the difference between the Payments (BoP, current US$) of Ireland and Payments (BoP, current US$) of Mongolia?
Provide a succinct answer. 3.35e+11. In the year 2007, what is the difference between the Payments (BoP, current US$) in Kazakhstan and Payments (BoP, current US$) in Kyrgyz Republic?
Ensure brevity in your answer.  5.84e+1. In the year 2007, what is the difference between the Payments (BoP, current US$) in Kazakhstan and Payments (BoP, current US$) in Mongolia?
Give a very brief answer. 5.91e+1. In the year 2007, what is the difference between the Payments (BoP, current US$) of Kyrgyz Republic and Payments (BoP, current US$) of Mongolia?
Your answer should be compact. 6.85e+08. In the year 2008, what is the difference between the Payments (BoP, current US$) in Ireland and Payments (BoP, current US$) in Kazakhstan?
Provide a succinct answer. 2.83e+11. In the year 2008, what is the difference between the Payments (BoP, current US$) in Ireland and Payments (BoP, current US$) in Kyrgyz Republic?
Your answer should be very brief. 3.51e+11. In the year 2008, what is the difference between the Payments (BoP, current US$) of Ireland and Payments (BoP, current US$) of Mongolia?
Offer a very short reply. 3.52e+11. In the year 2008, what is the difference between the Payments (BoP, current US$) of Kazakhstan and Payments (BoP, current US$) of Kyrgyz Republic?
Offer a very short reply. 6.78e+1. In the year 2008, what is the difference between the Payments (BoP, current US$) in Kazakhstan and Payments (BoP, current US$) in Mongolia?
Offer a terse response. 6.87e+1. In the year 2008, what is the difference between the Payments (BoP, current US$) in Kyrgyz Republic and Payments (BoP, current US$) in Mongolia?
Your answer should be compact. 9.56e+08. In the year 2009, what is the difference between the Payments (BoP, current US$) in Ireland and Payments (BoP, current US$) in Kazakhstan?
Provide a succinct answer. 2.27e+11. In the year 2009, what is the difference between the Payments (BoP, current US$) in Ireland and Payments (BoP, current US$) in Kyrgyz Republic?
Offer a terse response. 2.78e+11. In the year 2009, what is the difference between the Payments (BoP, current US$) in Ireland and Payments (BoP, current US$) in Mongolia?
Give a very brief answer. 2.79e+11. In the year 2009, what is the difference between the Payments (BoP, current US$) in Kazakhstan and Payments (BoP, current US$) in Kyrgyz Republic?
Make the answer very short. 5.08e+1. In the year 2009, what is the difference between the Payments (BoP, current US$) of Kazakhstan and Payments (BoP, current US$) of Mongolia?
Your answer should be very brief. 5.17e+1. In the year 2009, what is the difference between the Payments (BoP, current US$) of Kyrgyz Republic and Payments (BoP, current US$) of Mongolia?
Offer a very short reply. 9.13e+08. In the year 2010, what is the difference between the Payments (BoP, current US$) of Ireland and Payments (BoP, current US$) of Kazakhstan?
Give a very brief answer. 2.13e+11. In the year 2010, what is the difference between the Payments (BoP, current US$) of Ireland and Payments (BoP, current US$) of Kyrgyz Republic?
Your response must be concise. 2.75e+11. In the year 2010, what is the difference between the Payments (BoP, current US$) in Ireland and Payments (BoP, current US$) in Mongolia?
Provide a short and direct response. 2.75e+11. In the year 2010, what is the difference between the Payments (BoP, current US$) of Kazakhstan and Payments (BoP, current US$) of Kyrgyz Republic?
Make the answer very short. 6.22e+1. In the year 2010, what is the difference between the Payments (BoP, current US$) in Kazakhstan and Payments (BoP, current US$) in Mongolia?
Your answer should be very brief. 6.18e+1. In the year 2010, what is the difference between the Payments (BoP, current US$) of Kyrgyz Republic and Payments (BoP, current US$) of Mongolia?
Make the answer very short. -3.79e+08. In the year 2011, what is the difference between the Payments (BoP, current US$) in Ireland and Payments (BoP, current US$) in Kazakhstan?
Make the answer very short. 2.25e+11. In the year 2011, what is the difference between the Payments (BoP, current US$) in Ireland and Payments (BoP, current US$) in Kyrgyz Republic?
Provide a succinct answer. 3.01e+11. In the year 2011, what is the difference between the Payments (BoP, current US$) of Ireland and Payments (BoP, current US$) of Mongolia?
Offer a very short reply. 2.98e+11. In the year 2011, what is the difference between the Payments (BoP, current US$) of Kazakhstan and Payments (BoP, current US$) of Kyrgyz Republic?
Make the answer very short. 7.57e+1. In the year 2011, what is the difference between the Payments (BoP, current US$) of Kazakhstan and Payments (BoP, current US$) of Mongolia?
Make the answer very short. 7.28e+1. In the year 2011, what is the difference between the Payments (BoP, current US$) in Kyrgyz Republic and Payments (BoP, current US$) in Mongolia?
Provide a succinct answer. -2.89e+09. In the year 2012, what is the difference between the Payments (BoP, current US$) in Ireland and Payments (BoP, current US$) in Kazakhstan?
Provide a short and direct response. 1.97e+11. In the year 2012, what is the difference between the Payments (BoP, current US$) of Ireland and Payments (BoP, current US$) of Kyrgyz Republic?
Make the answer very short. 2.82e+11. In the year 2012, what is the difference between the Payments (BoP, current US$) of Ireland and Payments (BoP, current US$) of Mongolia?
Offer a terse response. 2.80e+11. In the year 2012, what is the difference between the Payments (BoP, current US$) of Kazakhstan and Payments (BoP, current US$) of Kyrgyz Republic?
Provide a succinct answer. 8.51e+1. In the year 2012, what is the difference between the Payments (BoP, current US$) of Kazakhstan and Payments (BoP, current US$) of Mongolia?
Offer a terse response. 8.28e+1. In the year 2012, what is the difference between the Payments (BoP, current US$) of Kyrgyz Republic and Payments (BoP, current US$) of Mongolia?
Your answer should be compact. -2.32e+09. What is the ratio of the Payments (BoP, current US$) in Ireland in 2005 to that in 2006?
Keep it short and to the point. 0.84. What is the ratio of the Payments (BoP, current US$) of Kazakhstan in 2005 to that in 2006?
Your answer should be compact. 0.73. What is the ratio of the Payments (BoP, current US$) of Kyrgyz Republic in 2005 to that in 2006?
Ensure brevity in your answer.  0.64. What is the ratio of the Payments (BoP, current US$) of Mongolia in 2005 to that in 2006?
Offer a very short reply. 0.8. What is the ratio of the Payments (BoP, current US$) in Ireland in 2005 to that in 2007?
Ensure brevity in your answer.  0.66. What is the ratio of the Payments (BoP, current US$) in Kazakhstan in 2005 to that in 2007?
Ensure brevity in your answer.  0.52. What is the ratio of the Payments (BoP, current US$) of Kyrgyz Republic in 2005 to that in 2007?
Your answer should be very brief. 0.45. What is the ratio of the Payments (BoP, current US$) of Mongolia in 2005 to that in 2007?
Provide a short and direct response. 0.62. What is the ratio of the Payments (BoP, current US$) of Ireland in 2005 to that in 2008?
Provide a short and direct response. 0.63. What is the ratio of the Payments (BoP, current US$) in Kazakhstan in 2005 to that in 2008?
Make the answer very short. 0.44. What is the ratio of the Payments (BoP, current US$) of Kyrgyz Republic in 2005 to that in 2008?
Make the answer very short. 0.31. What is the ratio of the Payments (BoP, current US$) in Mongolia in 2005 to that in 2008?
Provide a short and direct response. 0.41. What is the ratio of the Payments (BoP, current US$) of Ireland in 2005 to that in 2009?
Ensure brevity in your answer.  0.8. What is the ratio of the Payments (BoP, current US$) in Kazakhstan in 2005 to that in 2009?
Your response must be concise. 0.59. What is the ratio of the Payments (BoP, current US$) of Kyrgyz Republic in 2005 to that in 2009?
Make the answer very short. 0.4. What is the ratio of the Payments (BoP, current US$) in Mongolia in 2005 to that in 2009?
Make the answer very short. 0.57. What is the ratio of the Payments (BoP, current US$) in Ireland in 2005 to that in 2010?
Provide a succinct answer. 0.8. What is the ratio of the Payments (BoP, current US$) of Kazakhstan in 2005 to that in 2010?
Offer a terse response. 0.48. What is the ratio of the Payments (BoP, current US$) of Kyrgyz Republic in 2005 to that in 2010?
Ensure brevity in your answer.  0.36. What is the ratio of the Payments (BoP, current US$) of Mongolia in 2005 to that in 2010?
Offer a terse response. 0.36. What is the ratio of the Payments (BoP, current US$) in Ireland in 2005 to that in 2011?
Your answer should be compact. 0.73. What is the ratio of the Payments (BoP, current US$) of Kazakhstan in 2005 to that in 2011?
Make the answer very short. 0.39. What is the ratio of the Payments (BoP, current US$) of Kyrgyz Republic in 2005 to that in 2011?
Keep it short and to the point. 0.27. What is the ratio of the Payments (BoP, current US$) of Mongolia in 2005 to that in 2011?
Give a very brief answer. 0.19. What is the ratio of the Payments (BoP, current US$) of Ireland in 2005 to that in 2012?
Provide a short and direct response. 0.77. What is the ratio of the Payments (BoP, current US$) in Kazakhstan in 2005 to that in 2012?
Offer a very short reply. 0.35. What is the ratio of the Payments (BoP, current US$) in Kyrgyz Republic in 2005 to that in 2012?
Provide a short and direct response. 0.22. What is the ratio of the Payments (BoP, current US$) of Mongolia in 2005 to that in 2012?
Your answer should be very brief. 0.18. What is the ratio of the Payments (BoP, current US$) in Ireland in 2006 to that in 2007?
Provide a succinct answer. 0.79. What is the ratio of the Payments (BoP, current US$) of Kazakhstan in 2006 to that in 2007?
Give a very brief answer. 0.71. What is the ratio of the Payments (BoP, current US$) in Kyrgyz Republic in 2006 to that in 2007?
Your answer should be very brief. 0.71. What is the ratio of the Payments (BoP, current US$) of Mongolia in 2006 to that in 2007?
Your response must be concise. 0.78. What is the ratio of the Payments (BoP, current US$) of Ireland in 2006 to that in 2008?
Give a very brief answer. 0.75. What is the ratio of the Payments (BoP, current US$) in Kazakhstan in 2006 to that in 2008?
Your response must be concise. 0.61. What is the ratio of the Payments (BoP, current US$) of Kyrgyz Republic in 2006 to that in 2008?
Ensure brevity in your answer.  0.48. What is the ratio of the Payments (BoP, current US$) of Mongolia in 2006 to that in 2008?
Provide a succinct answer. 0.52. What is the ratio of the Payments (BoP, current US$) of Ireland in 2006 to that in 2009?
Your response must be concise. 0.95. What is the ratio of the Payments (BoP, current US$) of Kazakhstan in 2006 to that in 2009?
Your response must be concise. 0.81. What is the ratio of the Payments (BoP, current US$) of Kyrgyz Republic in 2006 to that in 2009?
Provide a short and direct response. 0.62. What is the ratio of the Payments (BoP, current US$) in Mongolia in 2006 to that in 2009?
Keep it short and to the point. 0.72. What is the ratio of the Payments (BoP, current US$) in Ireland in 2006 to that in 2010?
Provide a short and direct response. 0.95. What is the ratio of the Payments (BoP, current US$) of Kazakhstan in 2006 to that in 2010?
Your answer should be very brief. 0.66. What is the ratio of the Payments (BoP, current US$) in Kyrgyz Republic in 2006 to that in 2010?
Provide a short and direct response. 0.57. What is the ratio of the Payments (BoP, current US$) of Mongolia in 2006 to that in 2010?
Ensure brevity in your answer.  0.45. What is the ratio of the Payments (BoP, current US$) of Ireland in 2006 to that in 2011?
Give a very brief answer. 0.87. What is the ratio of the Payments (BoP, current US$) of Kazakhstan in 2006 to that in 2011?
Provide a succinct answer. 0.54. What is the ratio of the Payments (BoP, current US$) in Kyrgyz Republic in 2006 to that in 2011?
Provide a short and direct response. 0.42. What is the ratio of the Payments (BoP, current US$) in Mongolia in 2006 to that in 2011?
Offer a very short reply. 0.24. What is the ratio of the Payments (BoP, current US$) in Ireland in 2006 to that in 2012?
Provide a short and direct response. 0.92. What is the ratio of the Payments (BoP, current US$) in Kazakhstan in 2006 to that in 2012?
Your answer should be compact. 0.48. What is the ratio of the Payments (BoP, current US$) in Kyrgyz Republic in 2006 to that in 2012?
Your answer should be compact. 0.35. What is the ratio of the Payments (BoP, current US$) in Mongolia in 2006 to that in 2012?
Your answer should be compact. 0.23. What is the ratio of the Payments (BoP, current US$) of Ireland in 2007 to that in 2008?
Keep it short and to the point. 0.95. What is the ratio of the Payments (BoP, current US$) in Kazakhstan in 2007 to that in 2008?
Offer a terse response. 0.85. What is the ratio of the Payments (BoP, current US$) in Kyrgyz Republic in 2007 to that in 2008?
Your response must be concise. 0.67. What is the ratio of the Payments (BoP, current US$) in Mongolia in 2007 to that in 2008?
Provide a short and direct response. 0.66. What is the ratio of the Payments (BoP, current US$) in Ireland in 2007 to that in 2009?
Offer a very short reply. 1.2. What is the ratio of the Payments (BoP, current US$) in Kazakhstan in 2007 to that in 2009?
Ensure brevity in your answer.  1.13. What is the ratio of the Payments (BoP, current US$) in Mongolia in 2007 to that in 2009?
Provide a short and direct response. 0.92. What is the ratio of the Payments (BoP, current US$) in Ireland in 2007 to that in 2010?
Ensure brevity in your answer.  1.21. What is the ratio of the Payments (BoP, current US$) in Kazakhstan in 2007 to that in 2010?
Provide a succinct answer. 0.93. What is the ratio of the Payments (BoP, current US$) of Kyrgyz Republic in 2007 to that in 2010?
Offer a very short reply. 0.8. What is the ratio of the Payments (BoP, current US$) of Mongolia in 2007 to that in 2010?
Your answer should be very brief. 0.58. What is the ratio of the Payments (BoP, current US$) of Ireland in 2007 to that in 2011?
Make the answer very short. 1.1. What is the ratio of the Payments (BoP, current US$) of Kazakhstan in 2007 to that in 2011?
Keep it short and to the point. 0.76. What is the ratio of the Payments (BoP, current US$) of Kyrgyz Republic in 2007 to that in 2011?
Give a very brief answer. 0.59. What is the ratio of the Payments (BoP, current US$) in Mongolia in 2007 to that in 2011?
Offer a very short reply. 0.31. What is the ratio of the Payments (BoP, current US$) in Ireland in 2007 to that in 2012?
Keep it short and to the point. 1.17. What is the ratio of the Payments (BoP, current US$) of Kazakhstan in 2007 to that in 2012?
Ensure brevity in your answer.  0.67. What is the ratio of the Payments (BoP, current US$) in Kyrgyz Republic in 2007 to that in 2012?
Your answer should be very brief. 0.5. What is the ratio of the Payments (BoP, current US$) in Mongolia in 2007 to that in 2012?
Give a very brief answer. 0.29. What is the ratio of the Payments (BoP, current US$) of Ireland in 2008 to that in 2009?
Your answer should be compact. 1.26. What is the ratio of the Payments (BoP, current US$) in Kazakhstan in 2008 to that in 2009?
Provide a short and direct response. 1.33. What is the ratio of the Payments (BoP, current US$) of Kyrgyz Republic in 2008 to that in 2009?
Give a very brief answer. 1.31. What is the ratio of the Payments (BoP, current US$) in Mongolia in 2008 to that in 2009?
Offer a very short reply. 1.39. What is the ratio of the Payments (BoP, current US$) in Ireland in 2008 to that in 2010?
Give a very brief answer. 1.27. What is the ratio of the Payments (BoP, current US$) of Kazakhstan in 2008 to that in 2010?
Provide a succinct answer. 1.1. What is the ratio of the Payments (BoP, current US$) of Kyrgyz Republic in 2008 to that in 2010?
Your answer should be very brief. 1.19. What is the ratio of the Payments (BoP, current US$) in Mongolia in 2008 to that in 2010?
Provide a short and direct response. 0.88. What is the ratio of the Payments (BoP, current US$) in Ireland in 2008 to that in 2011?
Your answer should be compact. 1.16. What is the ratio of the Payments (BoP, current US$) in Kazakhstan in 2008 to that in 2011?
Your response must be concise. 0.89. What is the ratio of the Payments (BoP, current US$) of Kyrgyz Republic in 2008 to that in 2011?
Offer a terse response. 0.88. What is the ratio of the Payments (BoP, current US$) of Mongolia in 2008 to that in 2011?
Provide a short and direct response. 0.47. What is the ratio of the Payments (BoP, current US$) in Ireland in 2008 to that in 2012?
Provide a short and direct response. 1.23. What is the ratio of the Payments (BoP, current US$) of Kazakhstan in 2008 to that in 2012?
Offer a very short reply. 0.79. What is the ratio of the Payments (BoP, current US$) in Kyrgyz Republic in 2008 to that in 2012?
Ensure brevity in your answer.  0.73. What is the ratio of the Payments (BoP, current US$) of Mongolia in 2008 to that in 2012?
Provide a short and direct response. 0.44. What is the ratio of the Payments (BoP, current US$) in Ireland in 2009 to that in 2010?
Offer a very short reply. 1.01. What is the ratio of the Payments (BoP, current US$) of Kazakhstan in 2009 to that in 2010?
Your answer should be compact. 0.82. What is the ratio of the Payments (BoP, current US$) in Kyrgyz Republic in 2009 to that in 2010?
Provide a succinct answer. 0.91. What is the ratio of the Payments (BoP, current US$) of Mongolia in 2009 to that in 2010?
Your response must be concise. 0.63. What is the ratio of the Payments (BoP, current US$) in Ireland in 2009 to that in 2011?
Give a very brief answer. 0.92. What is the ratio of the Payments (BoP, current US$) of Kazakhstan in 2009 to that in 2011?
Your response must be concise. 0.67. What is the ratio of the Payments (BoP, current US$) in Kyrgyz Republic in 2009 to that in 2011?
Provide a succinct answer. 0.67. What is the ratio of the Payments (BoP, current US$) in Mongolia in 2009 to that in 2011?
Provide a succinct answer. 0.34. What is the ratio of the Payments (BoP, current US$) in Ireland in 2009 to that in 2012?
Keep it short and to the point. 0.97. What is the ratio of the Payments (BoP, current US$) in Kazakhstan in 2009 to that in 2012?
Ensure brevity in your answer.  0.59. What is the ratio of the Payments (BoP, current US$) of Kyrgyz Republic in 2009 to that in 2012?
Your answer should be compact. 0.56. What is the ratio of the Payments (BoP, current US$) of Mongolia in 2009 to that in 2012?
Offer a very short reply. 0.32. What is the ratio of the Payments (BoP, current US$) of Ireland in 2010 to that in 2011?
Your answer should be compact. 0.91. What is the ratio of the Payments (BoP, current US$) in Kazakhstan in 2010 to that in 2011?
Keep it short and to the point. 0.82. What is the ratio of the Payments (BoP, current US$) of Kyrgyz Republic in 2010 to that in 2011?
Give a very brief answer. 0.74. What is the ratio of the Payments (BoP, current US$) in Mongolia in 2010 to that in 2011?
Your answer should be compact. 0.53. What is the ratio of the Payments (BoP, current US$) of Ireland in 2010 to that in 2012?
Offer a very short reply. 0.97. What is the ratio of the Payments (BoP, current US$) of Kazakhstan in 2010 to that in 2012?
Provide a short and direct response. 0.72. What is the ratio of the Payments (BoP, current US$) of Kyrgyz Republic in 2010 to that in 2012?
Make the answer very short. 0.62. What is the ratio of the Payments (BoP, current US$) in Mongolia in 2010 to that in 2012?
Give a very brief answer. 0.5. What is the ratio of the Payments (BoP, current US$) in Ireland in 2011 to that in 2012?
Give a very brief answer. 1.06. What is the ratio of the Payments (BoP, current US$) in Kazakhstan in 2011 to that in 2012?
Provide a short and direct response. 0.89. What is the ratio of the Payments (BoP, current US$) in Kyrgyz Republic in 2011 to that in 2012?
Make the answer very short. 0.84. What is the ratio of the Payments (BoP, current US$) of Mongolia in 2011 to that in 2012?
Keep it short and to the point. 0.94. What is the difference between the highest and the second highest Payments (BoP, current US$) of Ireland?
Provide a short and direct response. 1.85e+1. What is the difference between the highest and the second highest Payments (BoP, current US$) of Kazakhstan?
Your answer should be compact. 1.05e+1. What is the difference between the highest and the second highest Payments (BoP, current US$) of Kyrgyz Republic?
Provide a short and direct response. 1.10e+09. What is the difference between the highest and the second highest Payments (BoP, current US$) of Mongolia?
Your response must be concise. 5.24e+08. What is the difference between the highest and the lowest Payments (BoP, current US$) in Ireland?
Provide a short and direct response. 1.32e+11. What is the difference between the highest and the lowest Payments (BoP, current US$) in Kazakhstan?
Your answer should be compact. 5.97e+1. What is the difference between the highest and the lowest Payments (BoP, current US$) of Kyrgyz Republic?
Keep it short and to the point. 5.19e+09. What is the difference between the highest and the lowest Payments (BoP, current US$) in Mongolia?
Ensure brevity in your answer.  7.37e+09. 